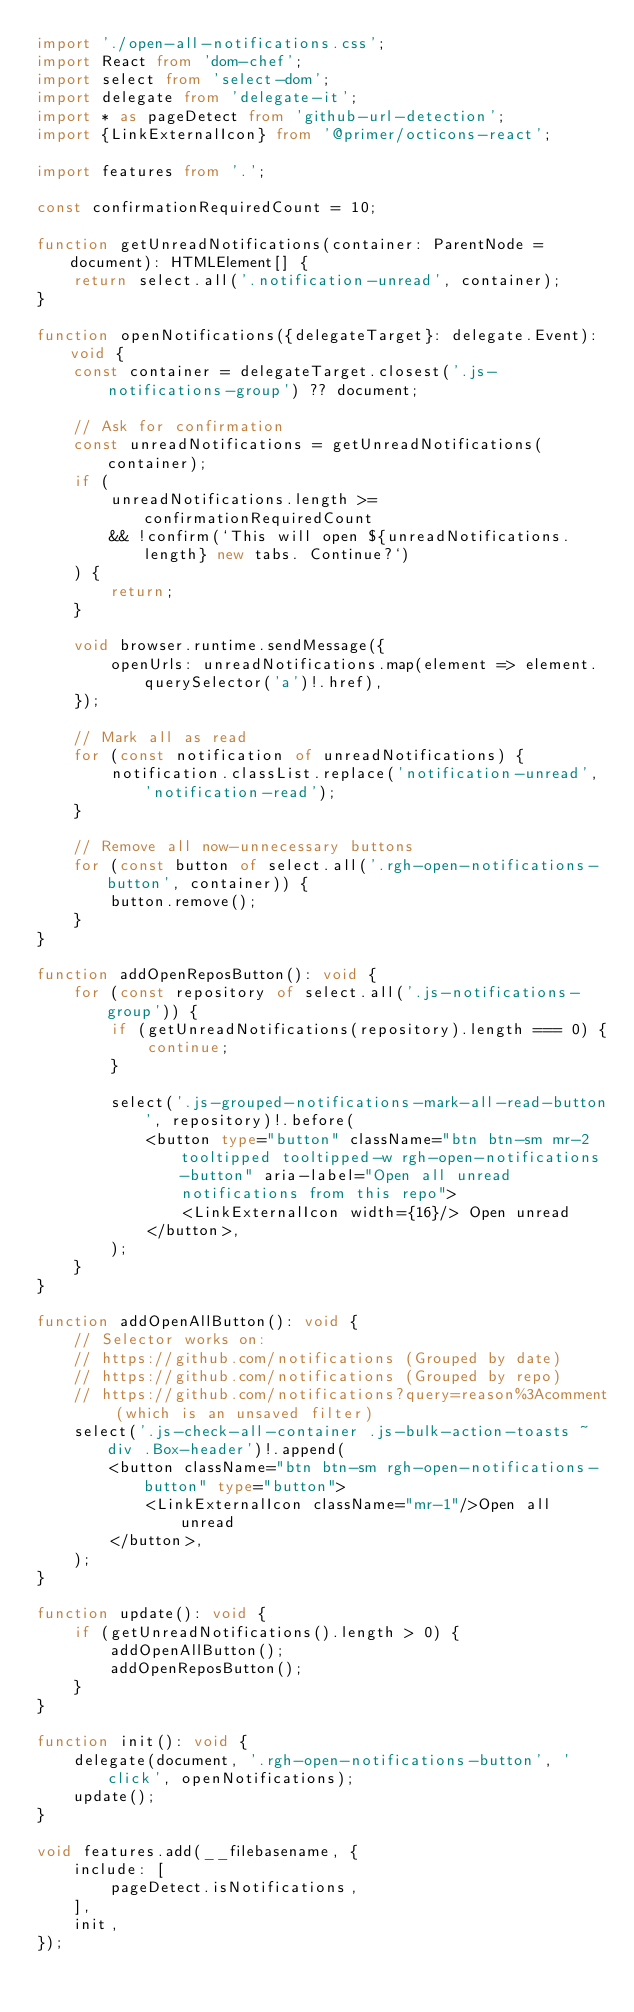<code> <loc_0><loc_0><loc_500><loc_500><_TypeScript_>import './open-all-notifications.css';
import React from 'dom-chef';
import select from 'select-dom';
import delegate from 'delegate-it';
import * as pageDetect from 'github-url-detection';
import {LinkExternalIcon} from '@primer/octicons-react';

import features from '.';

const confirmationRequiredCount = 10;

function getUnreadNotifications(container: ParentNode = document): HTMLElement[] {
	return select.all('.notification-unread', container);
}

function openNotifications({delegateTarget}: delegate.Event): void {
	const container = delegateTarget.closest('.js-notifications-group') ?? document;

	// Ask for confirmation
	const unreadNotifications = getUnreadNotifications(container);
	if (
		unreadNotifications.length >= confirmationRequiredCount
		&& !confirm(`This will open ${unreadNotifications.length} new tabs. Continue?`)
	) {
		return;
	}

	void browser.runtime.sendMessage({
		openUrls: unreadNotifications.map(element => element.querySelector('a')!.href),
	});

	// Mark all as read
	for (const notification of unreadNotifications) {
		notification.classList.replace('notification-unread', 'notification-read');
	}

	// Remove all now-unnecessary buttons
	for (const button of select.all('.rgh-open-notifications-button', container)) {
		button.remove();
	}
}

function addOpenReposButton(): void {
	for (const repository of select.all('.js-notifications-group')) {
		if (getUnreadNotifications(repository).length === 0) {
			continue;
		}

		select('.js-grouped-notifications-mark-all-read-button', repository)!.before(
			<button type="button" className="btn btn-sm mr-2 tooltipped tooltipped-w rgh-open-notifications-button" aria-label="Open all unread notifications from this repo">
				<LinkExternalIcon width={16}/> Open unread
			</button>,
		);
	}
}

function addOpenAllButton(): void {
	// Selector works on:
	// https://github.com/notifications (Grouped by date)
	// https://github.com/notifications (Grouped by repo)
	// https://github.com/notifications?query=reason%3Acomment (which is an unsaved filter)
	select('.js-check-all-container .js-bulk-action-toasts ~ div .Box-header')!.append(
		<button className="btn btn-sm rgh-open-notifications-button" type="button">
			<LinkExternalIcon className="mr-1"/>Open all unread
		</button>,
	);
}

function update(): void {
	if (getUnreadNotifications().length > 0) {
		addOpenAllButton();
		addOpenReposButton();
	}
}

function init(): void {
	delegate(document, '.rgh-open-notifications-button', 'click', openNotifications);
	update();
}

void features.add(__filebasename, {
	include: [
		pageDetect.isNotifications,
	],
	init,
});
</code> 